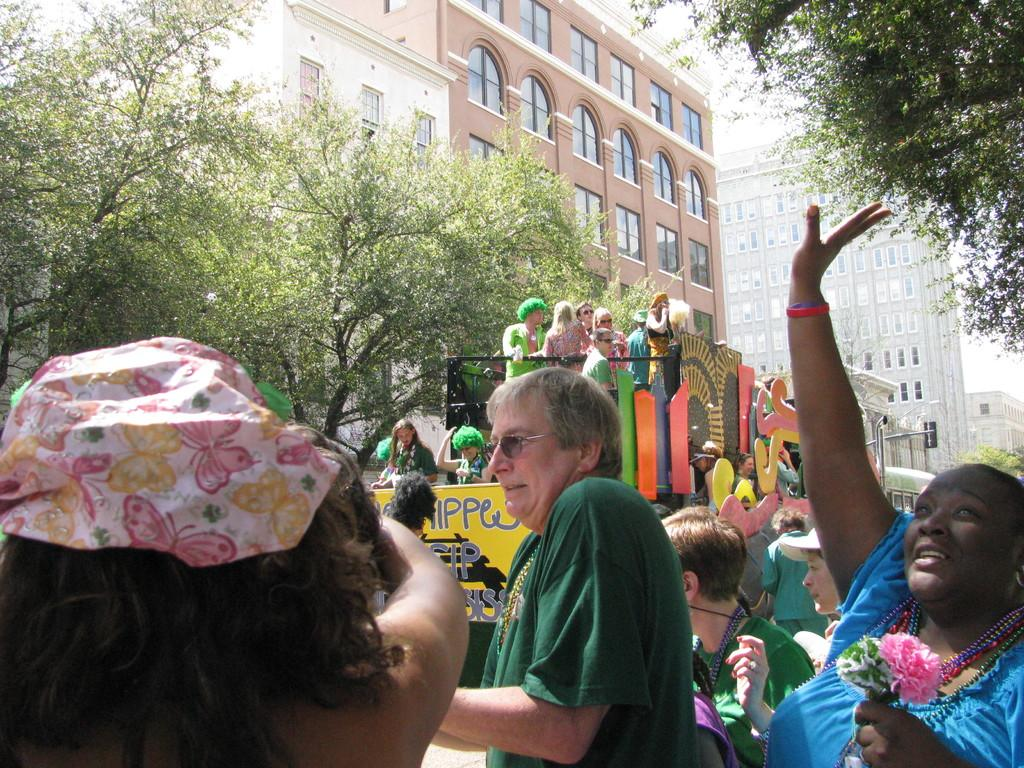What is happening in the image? There are people standing in the image, and some of them are inside a vehicle. Can you describe the vehicle in the image? There is a vehicle in the image, and people are inside it. What can be seen in the background of the image? There are trees, buildings, and the sky visible in the background of the image. What type of shoe is the turkey wearing in the image? There is no turkey or shoe present in the image. Is it raining in the image? The image does not provide any information about the weather, so we cannot determine if it is raining or not. 